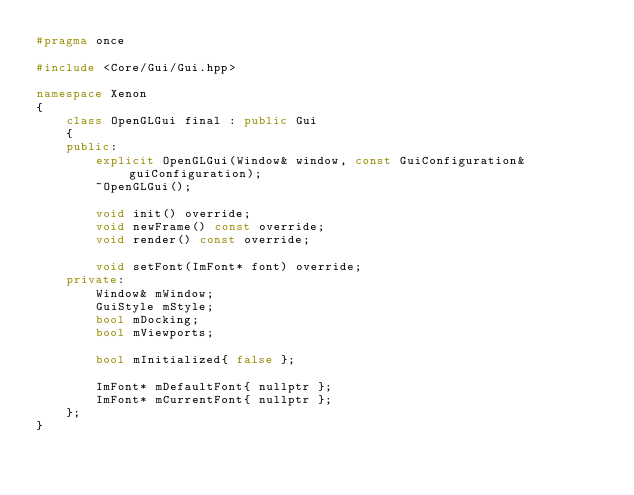Convert code to text. <code><loc_0><loc_0><loc_500><loc_500><_C++_>#pragma once

#include <Core/Gui/Gui.hpp>

namespace Xenon
{
    class OpenGLGui final : public Gui
    {
    public:
        explicit OpenGLGui(Window& window, const GuiConfiguration& guiConfiguration);
        ~OpenGLGui();

        void init() override;
        void newFrame() const override;
        void render() const override;

        void setFont(ImFont* font) override;
    private:
        Window& mWindow;
        GuiStyle mStyle;
        bool mDocking;
        bool mViewports;

        bool mInitialized{ false };

        ImFont* mDefaultFont{ nullptr };
        ImFont* mCurrentFont{ nullptr };
    };
}</code> 